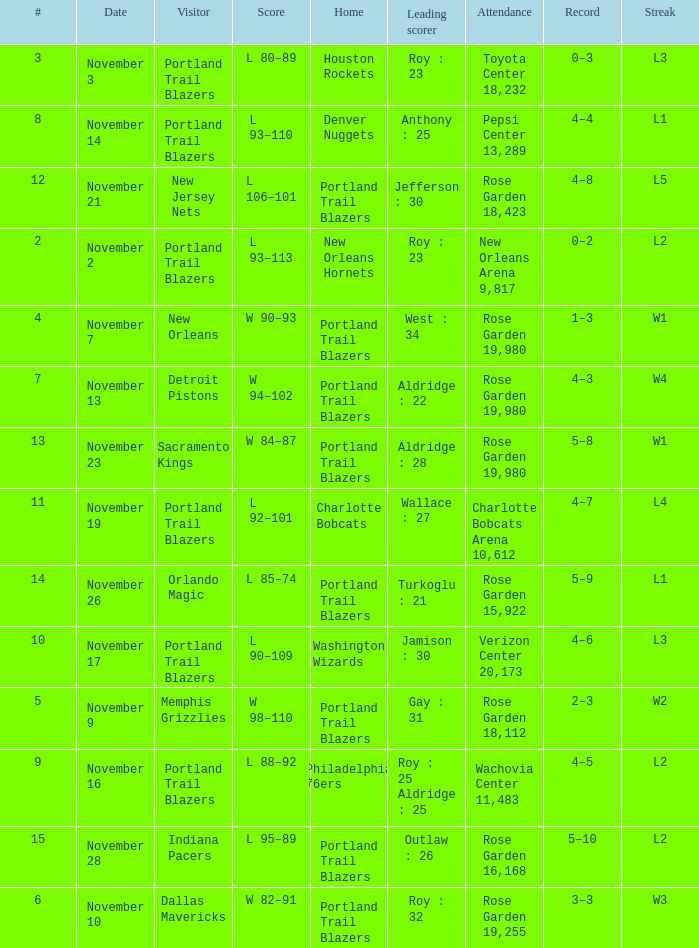 what's the score where record is 0–2 L 93–113. 